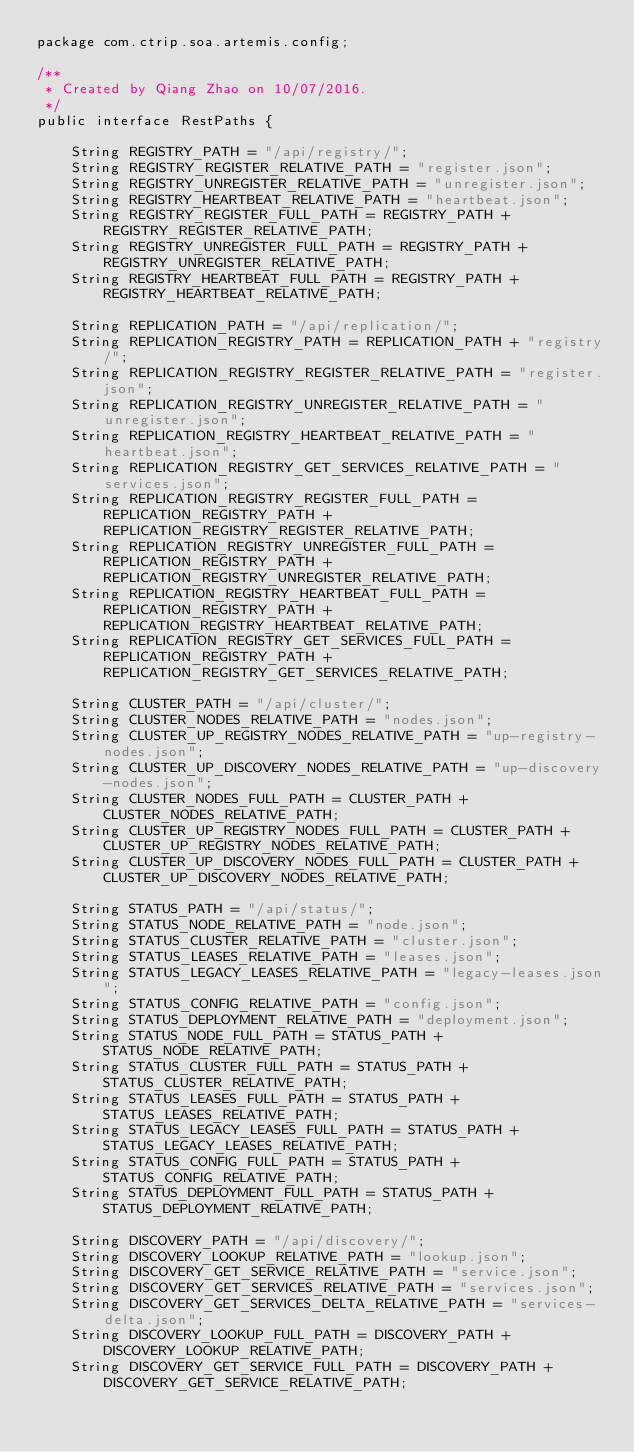Convert code to text. <code><loc_0><loc_0><loc_500><loc_500><_Java_>package com.ctrip.soa.artemis.config;

/**
 * Created by Qiang Zhao on 10/07/2016.
 */
public interface RestPaths {

    String REGISTRY_PATH = "/api/registry/";
    String REGISTRY_REGISTER_RELATIVE_PATH = "register.json";
    String REGISTRY_UNREGISTER_RELATIVE_PATH = "unregister.json";
    String REGISTRY_HEARTBEAT_RELATIVE_PATH = "heartbeat.json";
    String REGISTRY_REGISTER_FULL_PATH = REGISTRY_PATH + REGISTRY_REGISTER_RELATIVE_PATH;
    String REGISTRY_UNREGISTER_FULL_PATH = REGISTRY_PATH + REGISTRY_UNREGISTER_RELATIVE_PATH;
    String REGISTRY_HEARTBEAT_FULL_PATH = REGISTRY_PATH + REGISTRY_HEARTBEAT_RELATIVE_PATH;

    String REPLICATION_PATH = "/api/replication/";
    String REPLICATION_REGISTRY_PATH = REPLICATION_PATH + "registry/";
    String REPLICATION_REGISTRY_REGISTER_RELATIVE_PATH = "register.json";
    String REPLICATION_REGISTRY_UNREGISTER_RELATIVE_PATH = "unregister.json";
    String REPLICATION_REGISTRY_HEARTBEAT_RELATIVE_PATH = "heartbeat.json";
    String REPLICATION_REGISTRY_GET_SERVICES_RELATIVE_PATH = "services.json";
    String REPLICATION_REGISTRY_REGISTER_FULL_PATH = REPLICATION_REGISTRY_PATH + REPLICATION_REGISTRY_REGISTER_RELATIVE_PATH;
    String REPLICATION_REGISTRY_UNREGISTER_FULL_PATH = REPLICATION_REGISTRY_PATH + REPLICATION_REGISTRY_UNREGISTER_RELATIVE_PATH;
    String REPLICATION_REGISTRY_HEARTBEAT_FULL_PATH = REPLICATION_REGISTRY_PATH + REPLICATION_REGISTRY_HEARTBEAT_RELATIVE_PATH;
    String REPLICATION_REGISTRY_GET_SERVICES_FULL_PATH = REPLICATION_REGISTRY_PATH + REPLICATION_REGISTRY_GET_SERVICES_RELATIVE_PATH;

    String CLUSTER_PATH = "/api/cluster/";
    String CLUSTER_NODES_RELATIVE_PATH = "nodes.json";
    String CLUSTER_UP_REGISTRY_NODES_RELATIVE_PATH = "up-registry-nodes.json";
    String CLUSTER_UP_DISCOVERY_NODES_RELATIVE_PATH = "up-discovery-nodes.json";
    String CLUSTER_NODES_FULL_PATH = CLUSTER_PATH + CLUSTER_NODES_RELATIVE_PATH;
    String CLUSTER_UP_REGISTRY_NODES_FULL_PATH = CLUSTER_PATH + CLUSTER_UP_REGISTRY_NODES_RELATIVE_PATH;
    String CLUSTER_UP_DISCOVERY_NODES_FULL_PATH = CLUSTER_PATH + CLUSTER_UP_DISCOVERY_NODES_RELATIVE_PATH;

    String STATUS_PATH = "/api/status/";
    String STATUS_NODE_RELATIVE_PATH = "node.json";
    String STATUS_CLUSTER_RELATIVE_PATH = "cluster.json";
    String STATUS_LEASES_RELATIVE_PATH = "leases.json";
    String STATUS_LEGACY_LEASES_RELATIVE_PATH = "legacy-leases.json";
    String STATUS_CONFIG_RELATIVE_PATH = "config.json";
    String STATUS_DEPLOYMENT_RELATIVE_PATH = "deployment.json";
    String STATUS_NODE_FULL_PATH = STATUS_PATH + STATUS_NODE_RELATIVE_PATH;
    String STATUS_CLUSTER_FULL_PATH = STATUS_PATH + STATUS_CLUSTER_RELATIVE_PATH;
    String STATUS_LEASES_FULL_PATH = STATUS_PATH + STATUS_LEASES_RELATIVE_PATH;
    String STATUS_LEGACY_LEASES_FULL_PATH = STATUS_PATH + STATUS_LEGACY_LEASES_RELATIVE_PATH;
    String STATUS_CONFIG_FULL_PATH = STATUS_PATH + STATUS_CONFIG_RELATIVE_PATH;
    String STATUS_DEPLOYMENT_FULL_PATH = STATUS_PATH + STATUS_DEPLOYMENT_RELATIVE_PATH;

    String DISCOVERY_PATH = "/api/discovery/";
    String DISCOVERY_LOOKUP_RELATIVE_PATH = "lookup.json";
    String DISCOVERY_GET_SERVICE_RELATIVE_PATH = "service.json";
    String DISCOVERY_GET_SERVICES_RELATIVE_PATH = "services.json";
    String DISCOVERY_GET_SERVICES_DELTA_RELATIVE_PATH = "services-delta.json";
    String DISCOVERY_LOOKUP_FULL_PATH = DISCOVERY_PATH + DISCOVERY_LOOKUP_RELATIVE_PATH;
    String DISCOVERY_GET_SERVICE_FULL_PATH = DISCOVERY_PATH + DISCOVERY_GET_SERVICE_RELATIVE_PATH;</code> 